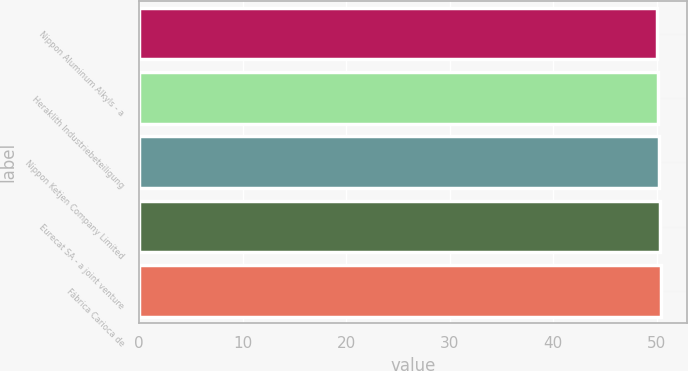Convert chart to OTSL. <chart><loc_0><loc_0><loc_500><loc_500><bar_chart><fcel>Nippon Aluminum Alkyls - a<fcel>Heraklith Industriebeteiligung<fcel>Nippon Ketjen Company Limited<fcel>Eurecat SA - a joint venture<fcel>Fábrica Carioca de<nl><fcel>50<fcel>50.1<fcel>50.2<fcel>50.3<fcel>50.4<nl></chart> 